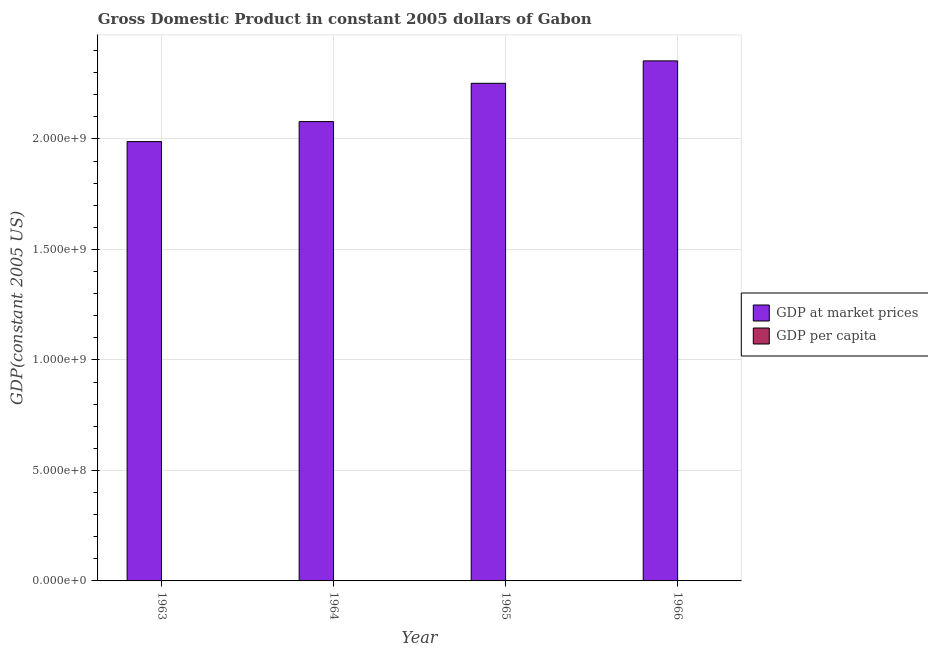How many different coloured bars are there?
Offer a terse response. 2. How many groups of bars are there?
Offer a very short reply. 4. Are the number of bars per tick equal to the number of legend labels?
Your answer should be very brief. Yes. Are the number of bars on each tick of the X-axis equal?
Make the answer very short. Yes. How many bars are there on the 4th tick from the left?
Provide a succinct answer. 2. What is the label of the 1st group of bars from the left?
Offer a terse response. 1963. What is the gdp at market prices in 1963?
Your answer should be compact. 1.99e+09. Across all years, what is the maximum gdp per capita?
Ensure brevity in your answer.  4337.52. Across all years, what is the minimum gdp per capita?
Keep it short and to the point. 3850.88. In which year was the gdp at market prices maximum?
Offer a terse response. 1966. What is the total gdp per capita in the graph?
Keep it short and to the point. 1.64e+04. What is the difference between the gdp at market prices in 1964 and that in 1965?
Provide a succinct answer. -1.73e+08. What is the difference between the gdp per capita in 1963 and the gdp at market prices in 1965?
Your response must be concise. -377.87. What is the average gdp per capita per year?
Ensure brevity in your answer.  4096.4. What is the ratio of the gdp at market prices in 1963 to that in 1965?
Your answer should be compact. 0.88. Is the gdp at market prices in 1963 less than that in 1966?
Offer a terse response. Yes. Is the difference between the gdp per capita in 1963 and 1965 greater than the difference between the gdp at market prices in 1963 and 1965?
Make the answer very short. No. What is the difference between the highest and the second highest gdp at market prices?
Give a very brief answer. 1.02e+08. What is the difference between the highest and the lowest gdp at market prices?
Ensure brevity in your answer.  3.65e+08. Is the sum of the gdp per capita in 1965 and 1966 greater than the maximum gdp at market prices across all years?
Your answer should be compact. Yes. What does the 1st bar from the left in 1964 represents?
Your answer should be compact. GDP at market prices. What does the 1st bar from the right in 1966 represents?
Provide a short and direct response. GDP per capita. How many bars are there?
Provide a short and direct response. 8. Are all the bars in the graph horizontal?
Make the answer very short. No. Are the values on the major ticks of Y-axis written in scientific E-notation?
Keep it short and to the point. Yes. Does the graph contain grids?
Provide a short and direct response. Yes. Where does the legend appear in the graph?
Your answer should be compact. Center right. What is the title of the graph?
Provide a short and direct response. Gross Domestic Product in constant 2005 dollars of Gabon. Does "Girls" appear as one of the legend labels in the graph?
Provide a short and direct response. No. What is the label or title of the Y-axis?
Keep it short and to the point. GDP(constant 2005 US). What is the GDP(constant 2005 US) in GDP at market prices in 1963?
Provide a short and direct response. 1.99e+09. What is the GDP(constant 2005 US) of GDP per capita in 1963?
Offer a very short reply. 3850.88. What is the GDP(constant 2005 US) of GDP at market prices in 1964?
Your response must be concise. 2.08e+09. What is the GDP(constant 2005 US) of GDP per capita in 1964?
Provide a succinct answer. 3968.44. What is the GDP(constant 2005 US) in GDP at market prices in 1965?
Offer a very short reply. 2.25e+09. What is the GDP(constant 2005 US) in GDP per capita in 1965?
Give a very brief answer. 4228.75. What is the GDP(constant 2005 US) of GDP at market prices in 1966?
Your answer should be compact. 2.35e+09. What is the GDP(constant 2005 US) in GDP per capita in 1966?
Give a very brief answer. 4337.52. Across all years, what is the maximum GDP(constant 2005 US) of GDP at market prices?
Provide a succinct answer. 2.35e+09. Across all years, what is the maximum GDP(constant 2005 US) in GDP per capita?
Your answer should be very brief. 4337.52. Across all years, what is the minimum GDP(constant 2005 US) of GDP at market prices?
Your response must be concise. 1.99e+09. Across all years, what is the minimum GDP(constant 2005 US) in GDP per capita?
Your answer should be very brief. 3850.88. What is the total GDP(constant 2005 US) in GDP at market prices in the graph?
Give a very brief answer. 8.67e+09. What is the total GDP(constant 2005 US) in GDP per capita in the graph?
Ensure brevity in your answer.  1.64e+04. What is the difference between the GDP(constant 2005 US) of GDP at market prices in 1963 and that in 1964?
Make the answer very short. -9.05e+07. What is the difference between the GDP(constant 2005 US) of GDP per capita in 1963 and that in 1964?
Offer a very short reply. -117.56. What is the difference between the GDP(constant 2005 US) in GDP at market prices in 1963 and that in 1965?
Make the answer very short. -2.64e+08. What is the difference between the GDP(constant 2005 US) of GDP per capita in 1963 and that in 1965?
Offer a terse response. -377.87. What is the difference between the GDP(constant 2005 US) of GDP at market prices in 1963 and that in 1966?
Offer a terse response. -3.65e+08. What is the difference between the GDP(constant 2005 US) of GDP per capita in 1963 and that in 1966?
Ensure brevity in your answer.  -486.64. What is the difference between the GDP(constant 2005 US) of GDP at market prices in 1964 and that in 1965?
Your response must be concise. -1.73e+08. What is the difference between the GDP(constant 2005 US) of GDP per capita in 1964 and that in 1965?
Provide a succinct answer. -260.31. What is the difference between the GDP(constant 2005 US) in GDP at market prices in 1964 and that in 1966?
Give a very brief answer. -2.75e+08. What is the difference between the GDP(constant 2005 US) in GDP per capita in 1964 and that in 1966?
Make the answer very short. -369.08. What is the difference between the GDP(constant 2005 US) of GDP at market prices in 1965 and that in 1966?
Give a very brief answer. -1.02e+08. What is the difference between the GDP(constant 2005 US) in GDP per capita in 1965 and that in 1966?
Offer a terse response. -108.77. What is the difference between the GDP(constant 2005 US) in GDP at market prices in 1963 and the GDP(constant 2005 US) in GDP per capita in 1964?
Offer a terse response. 1.99e+09. What is the difference between the GDP(constant 2005 US) in GDP at market prices in 1963 and the GDP(constant 2005 US) in GDP per capita in 1965?
Provide a succinct answer. 1.99e+09. What is the difference between the GDP(constant 2005 US) of GDP at market prices in 1963 and the GDP(constant 2005 US) of GDP per capita in 1966?
Ensure brevity in your answer.  1.99e+09. What is the difference between the GDP(constant 2005 US) of GDP at market prices in 1964 and the GDP(constant 2005 US) of GDP per capita in 1965?
Ensure brevity in your answer.  2.08e+09. What is the difference between the GDP(constant 2005 US) of GDP at market prices in 1964 and the GDP(constant 2005 US) of GDP per capita in 1966?
Provide a succinct answer. 2.08e+09. What is the difference between the GDP(constant 2005 US) in GDP at market prices in 1965 and the GDP(constant 2005 US) in GDP per capita in 1966?
Your response must be concise. 2.25e+09. What is the average GDP(constant 2005 US) in GDP at market prices per year?
Keep it short and to the point. 2.17e+09. What is the average GDP(constant 2005 US) in GDP per capita per year?
Your answer should be compact. 4096.4. In the year 1963, what is the difference between the GDP(constant 2005 US) of GDP at market prices and GDP(constant 2005 US) of GDP per capita?
Provide a short and direct response. 1.99e+09. In the year 1964, what is the difference between the GDP(constant 2005 US) of GDP at market prices and GDP(constant 2005 US) of GDP per capita?
Offer a terse response. 2.08e+09. In the year 1965, what is the difference between the GDP(constant 2005 US) in GDP at market prices and GDP(constant 2005 US) in GDP per capita?
Provide a succinct answer. 2.25e+09. In the year 1966, what is the difference between the GDP(constant 2005 US) of GDP at market prices and GDP(constant 2005 US) of GDP per capita?
Your answer should be compact. 2.35e+09. What is the ratio of the GDP(constant 2005 US) in GDP at market prices in 1963 to that in 1964?
Ensure brevity in your answer.  0.96. What is the ratio of the GDP(constant 2005 US) in GDP per capita in 1963 to that in 1964?
Keep it short and to the point. 0.97. What is the ratio of the GDP(constant 2005 US) in GDP at market prices in 1963 to that in 1965?
Your response must be concise. 0.88. What is the ratio of the GDP(constant 2005 US) in GDP per capita in 1963 to that in 1965?
Offer a terse response. 0.91. What is the ratio of the GDP(constant 2005 US) in GDP at market prices in 1963 to that in 1966?
Give a very brief answer. 0.84. What is the ratio of the GDP(constant 2005 US) of GDP per capita in 1963 to that in 1966?
Your answer should be compact. 0.89. What is the ratio of the GDP(constant 2005 US) in GDP per capita in 1964 to that in 1965?
Your response must be concise. 0.94. What is the ratio of the GDP(constant 2005 US) in GDP at market prices in 1964 to that in 1966?
Give a very brief answer. 0.88. What is the ratio of the GDP(constant 2005 US) in GDP per capita in 1964 to that in 1966?
Offer a very short reply. 0.91. What is the ratio of the GDP(constant 2005 US) of GDP at market prices in 1965 to that in 1966?
Give a very brief answer. 0.96. What is the ratio of the GDP(constant 2005 US) of GDP per capita in 1965 to that in 1966?
Your answer should be very brief. 0.97. What is the difference between the highest and the second highest GDP(constant 2005 US) in GDP at market prices?
Give a very brief answer. 1.02e+08. What is the difference between the highest and the second highest GDP(constant 2005 US) in GDP per capita?
Offer a very short reply. 108.77. What is the difference between the highest and the lowest GDP(constant 2005 US) of GDP at market prices?
Keep it short and to the point. 3.65e+08. What is the difference between the highest and the lowest GDP(constant 2005 US) of GDP per capita?
Ensure brevity in your answer.  486.64. 